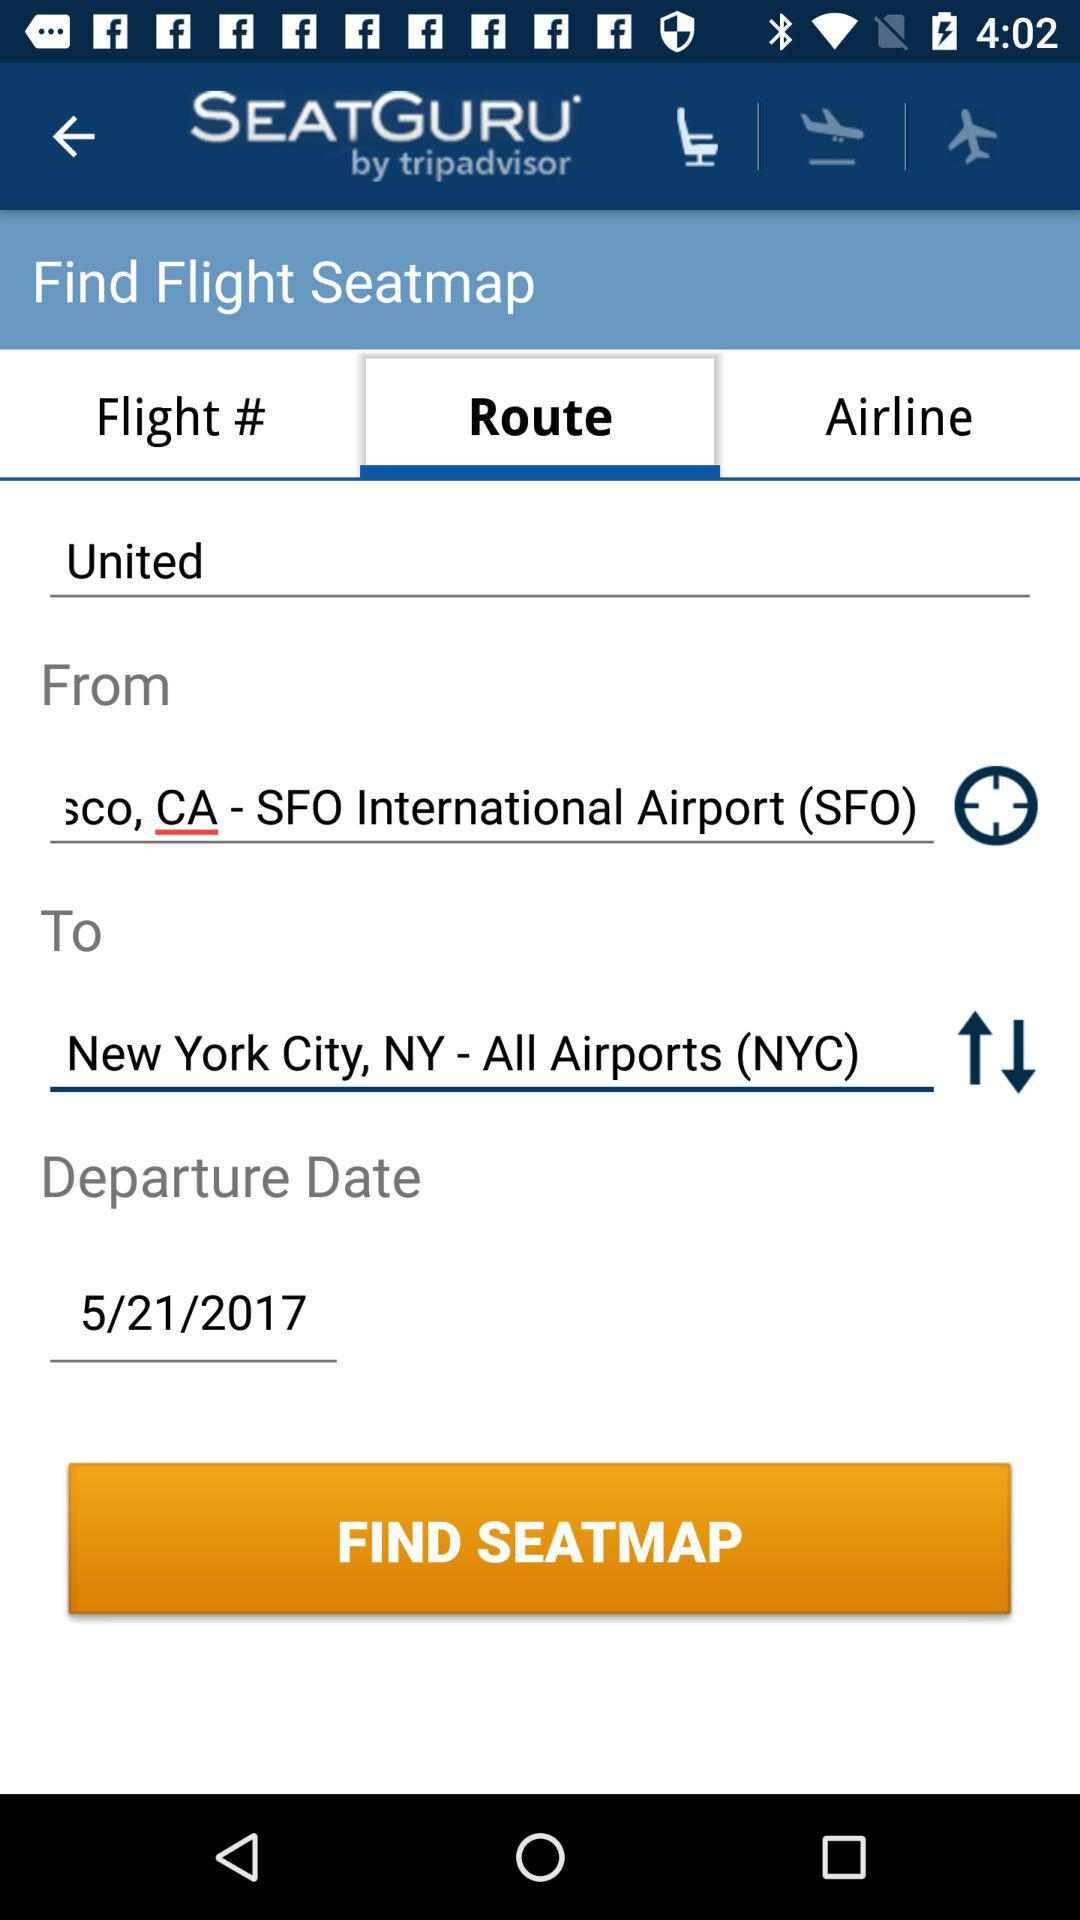Who developed the application? The application was developed by "tripadvisor". 